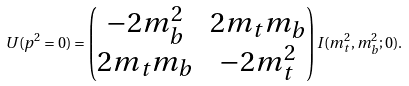Convert formula to latex. <formula><loc_0><loc_0><loc_500><loc_500>U ( p ^ { 2 } = 0 ) = \begin{pmatrix} - 2 m _ { b } ^ { 2 } & 2 m _ { t } m _ { b } \\ 2 m _ { t } m _ { b } & - 2 m _ { t } ^ { 2 } \end{pmatrix} I ( m _ { t } ^ { 2 } , m _ { b } ^ { 2 } ; 0 ) .</formula> 